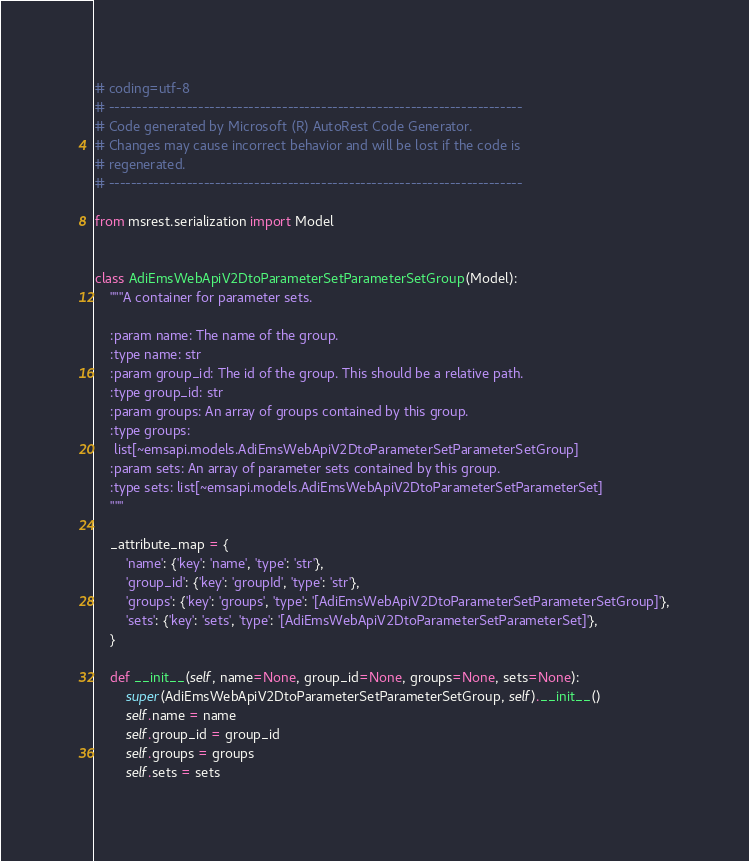<code> <loc_0><loc_0><loc_500><loc_500><_Python_># coding=utf-8
# --------------------------------------------------------------------------
# Code generated by Microsoft (R) AutoRest Code Generator.
# Changes may cause incorrect behavior and will be lost if the code is
# regenerated.
# --------------------------------------------------------------------------

from msrest.serialization import Model


class AdiEmsWebApiV2DtoParameterSetParameterSetGroup(Model):
    """A container for parameter sets.

    :param name: The name of the group.
    :type name: str
    :param group_id: The id of the group. This should be a relative path.
    :type group_id: str
    :param groups: An array of groups contained by this group.
    :type groups:
     list[~emsapi.models.AdiEmsWebApiV2DtoParameterSetParameterSetGroup]
    :param sets: An array of parameter sets contained by this group.
    :type sets: list[~emsapi.models.AdiEmsWebApiV2DtoParameterSetParameterSet]
    """

    _attribute_map = {
        'name': {'key': 'name', 'type': 'str'},
        'group_id': {'key': 'groupId', 'type': 'str'},
        'groups': {'key': 'groups', 'type': '[AdiEmsWebApiV2DtoParameterSetParameterSetGroup]'},
        'sets': {'key': 'sets', 'type': '[AdiEmsWebApiV2DtoParameterSetParameterSet]'},
    }

    def __init__(self, name=None, group_id=None, groups=None, sets=None):
        super(AdiEmsWebApiV2DtoParameterSetParameterSetGroup, self).__init__()
        self.name = name
        self.group_id = group_id
        self.groups = groups
        self.sets = sets
</code> 